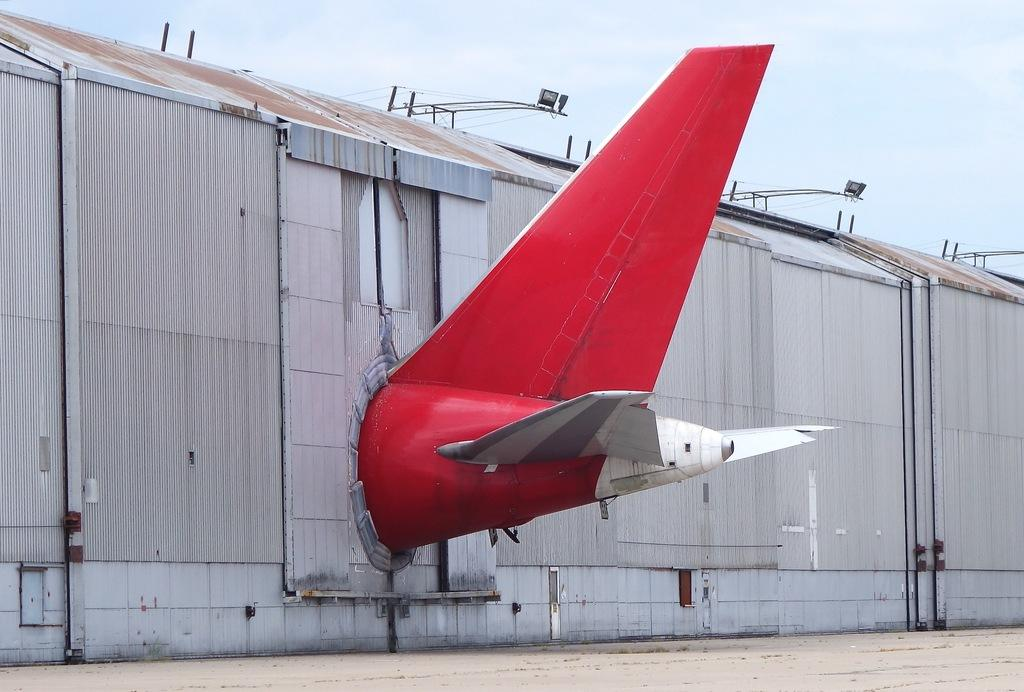What type of structure can be seen in the image? There is a shed in the image. What other object related to transportation is visible? There is a part of a plane in the image. What pathway is present at the bottom of the image? There is a walkway at the bottom of the image. What can be seen in the distance in the image? The sky is visible in the background of the image. What type of disgust can be seen on the stem of the plant in the image? There is no plant or stem present in the image. What town is visible in the background of the image? There is no town visible in the image; only the sky is visible in the background. 